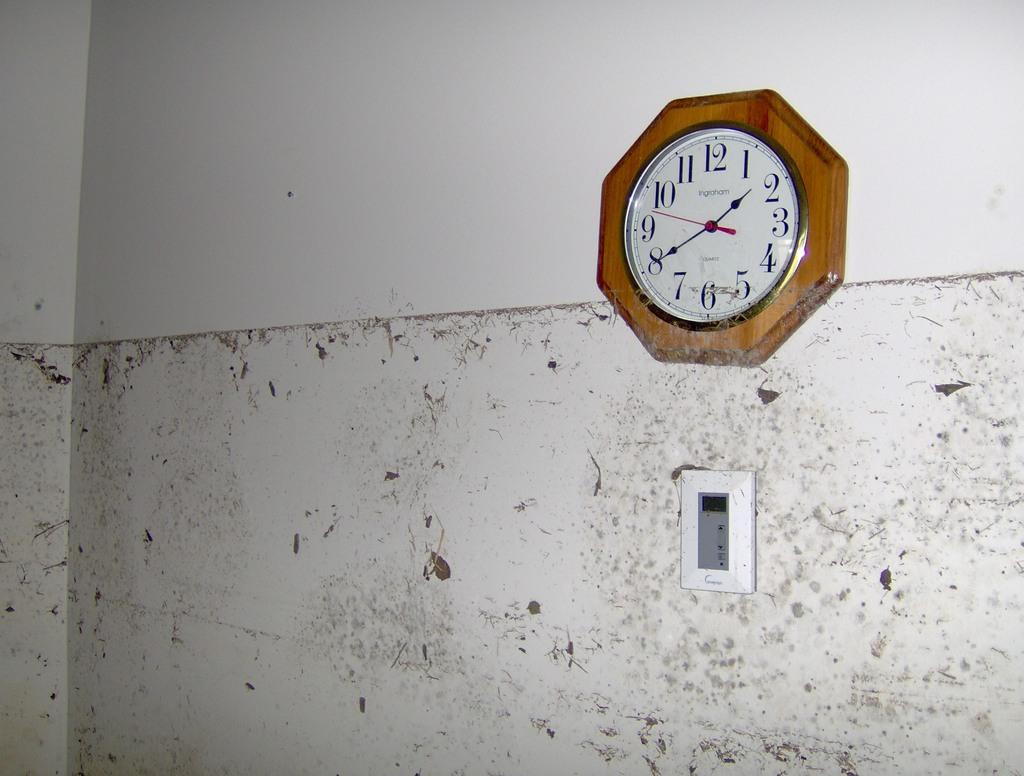What time is it?
Offer a very short reply. 1:40. What is the highest number on the clock?
Offer a very short reply. 12. 